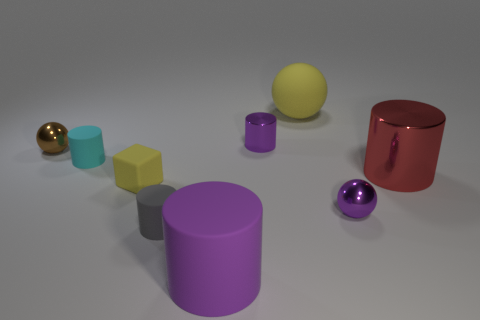Subtract all red cylinders. How many cylinders are left? 4 Subtract all blue cylinders. Subtract all purple balls. How many cylinders are left? 5 Subtract all balls. How many objects are left? 6 Add 7 large yellow things. How many large yellow things exist? 8 Subtract 0 blue balls. How many objects are left? 9 Subtract all yellow rubber balls. Subtract all brown metallic things. How many objects are left? 7 Add 7 spheres. How many spheres are left? 10 